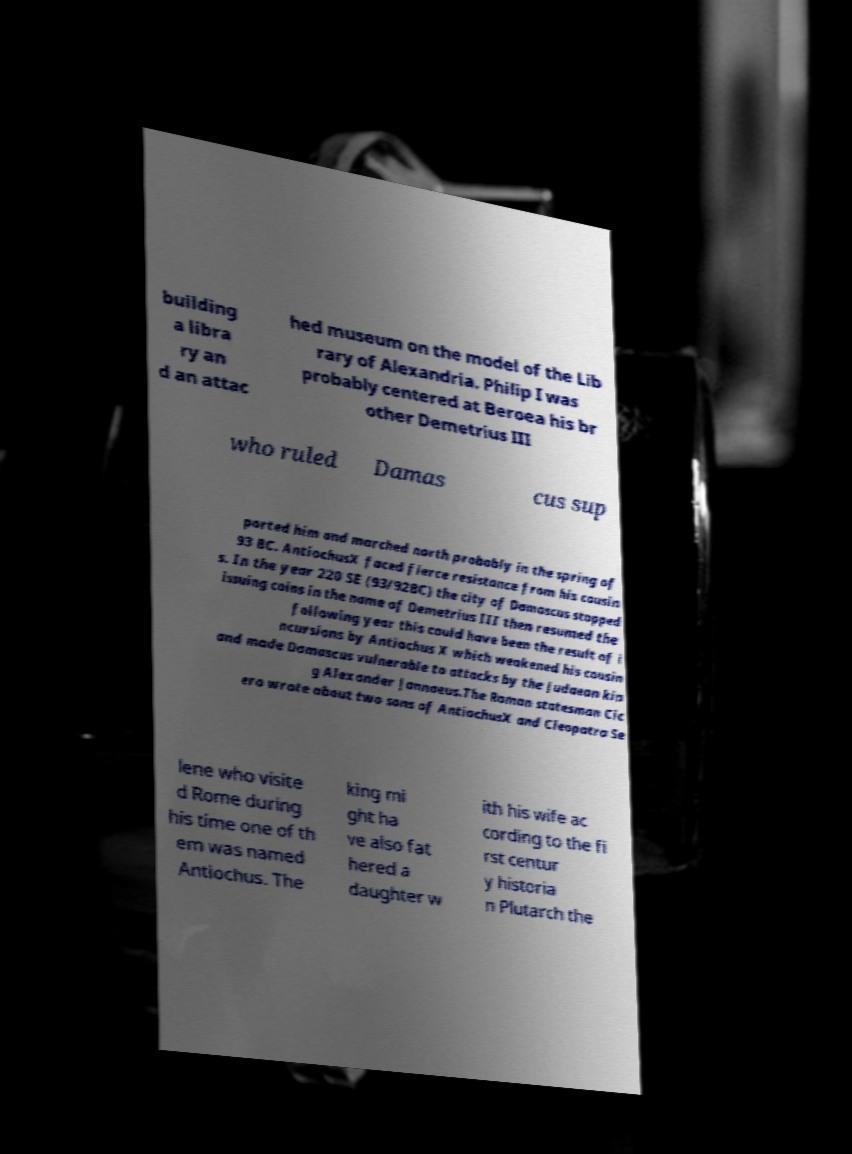Could you extract and type out the text from this image? building a libra ry an d an attac hed museum on the model of the Lib rary of Alexandria. Philip I was probably centered at Beroea his br other Demetrius III who ruled Damas cus sup ported him and marched north probably in the spring of 93 BC. AntiochusX faced fierce resistance from his cousin s. In the year 220 SE (93/92BC) the city of Damascus stopped issuing coins in the name of Demetrius III then resumed the following year this could have been the result of i ncursions by Antiochus X which weakened his cousin and made Damascus vulnerable to attacks by the Judaean kin g Alexander Jannaeus.The Roman statesman Cic ero wrote about two sons of AntiochusX and Cleopatra Se lene who visite d Rome during his time one of th em was named Antiochus. The king mi ght ha ve also fat hered a daughter w ith his wife ac cording to the fi rst centur y historia n Plutarch the 